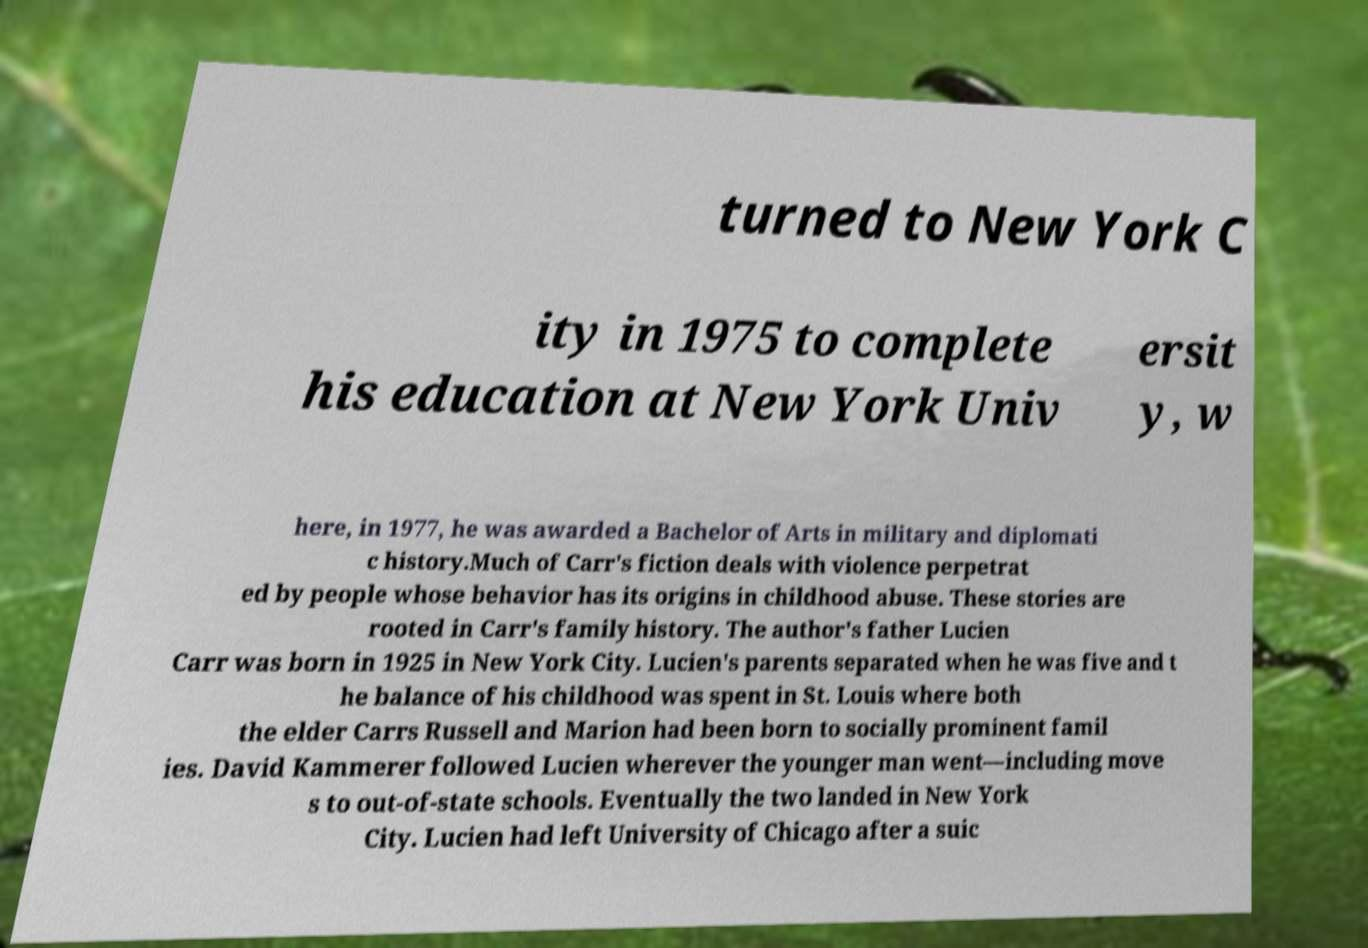I need the written content from this picture converted into text. Can you do that? turned to New York C ity in 1975 to complete his education at New York Univ ersit y, w here, in 1977, he was awarded a Bachelor of Arts in military and diplomati c history.Much of Carr's fiction deals with violence perpetrat ed by people whose behavior has its origins in childhood abuse. These stories are rooted in Carr's family history. The author's father Lucien Carr was born in 1925 in New York City. Lucien's parents separated when he was five and t he balance of his childhood was spent in St. Louis where both the elder Carrs Russell and Marion had been born to socially prominent famil ies. David Kammerer followed Lucien wherever the younger man went—including move s to out-of-state schools. Eventually the two landed in New York City. Lucien had left University of Chicago after a suic 